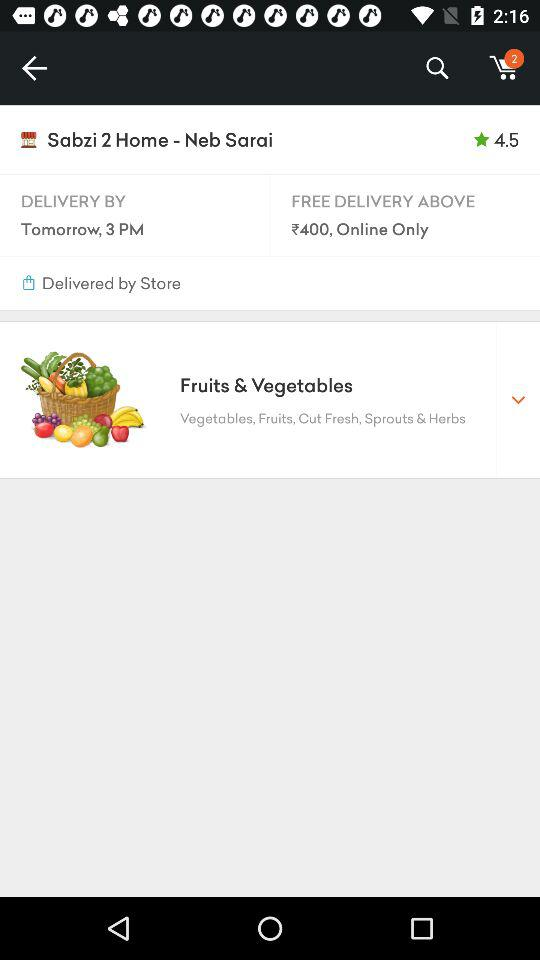From where will the order be delivered? The order will be delivered from "Sabzi 2 Home". 